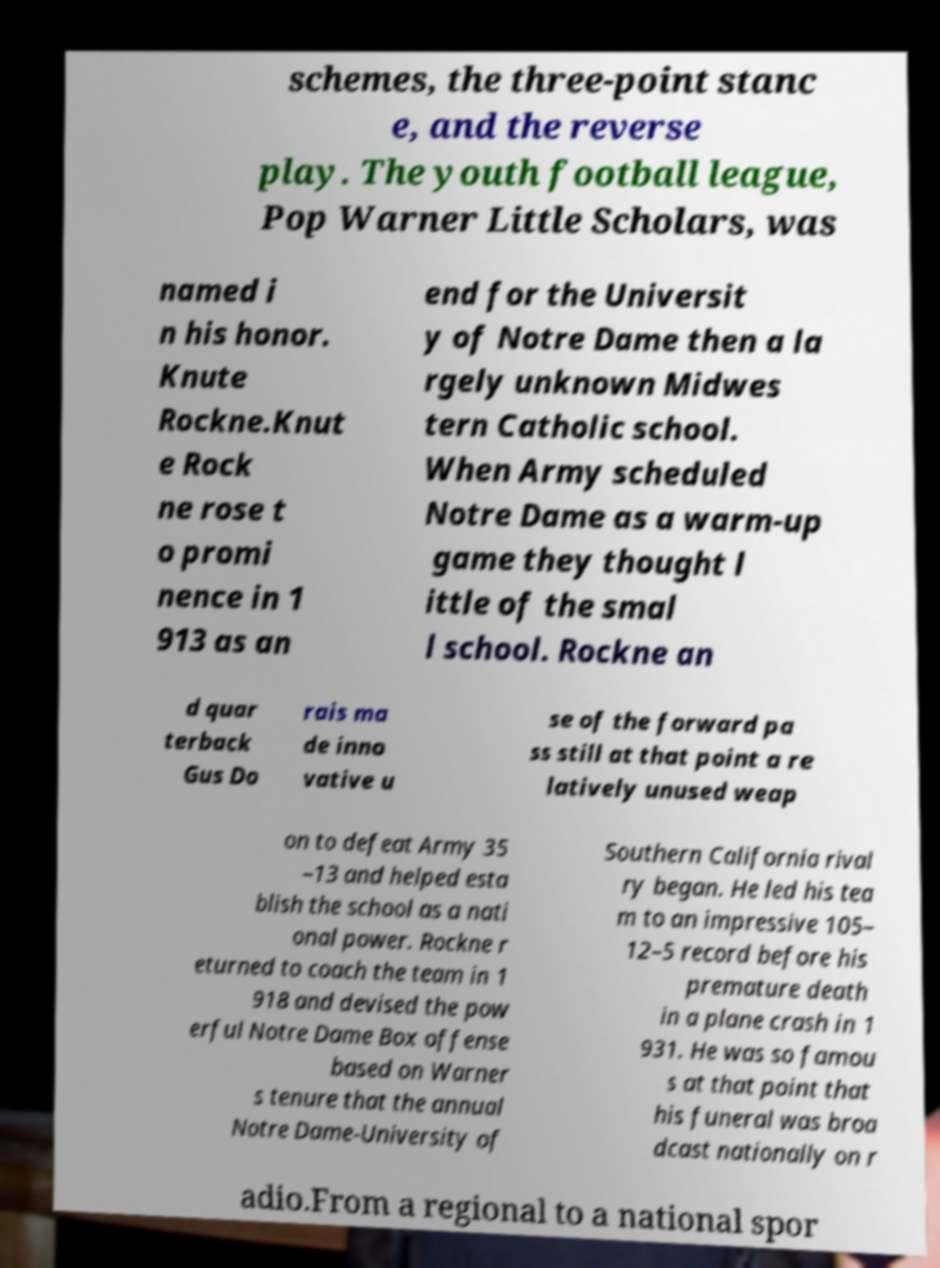Can you read and provide the text displayed in the image?This photo seems to have some interesting text. Can you extract and type it out for me? schemes, the three-point stanc e, and the reverse play. The youth football league, Pop Warner Little Scholars, was named i n his honor. Knute Rockne.Knut e Rock ne rose t o promi nence in 1 913 as an end for the Universit y of Notre Dame then a la rgely unknown Midwes tern Catholic school. When Army scheduled Notre Dame as a warm-up game they thought l ittle of the smal l school. Rockne an d quar terback Gus Do rais ma de inno vative u se of the forward pa ss still at that point a re latively unused weap on to defeat Army 35 –13 and helped esta blish the school as a nati onal power. Rockne r eturned to coach the team in 1 918 and devised the pow erful Notre Dame Box offense based on Warner s tenure that the annual Notre Dame-University of Southern California rival ry began. He led his tea m to an impressive 105– 12–5 record before his premature death in a plane crash in 1 931. He was so famou s at that point that his funeral was broa dcast nationally on r adio.From a regional to a national spor 